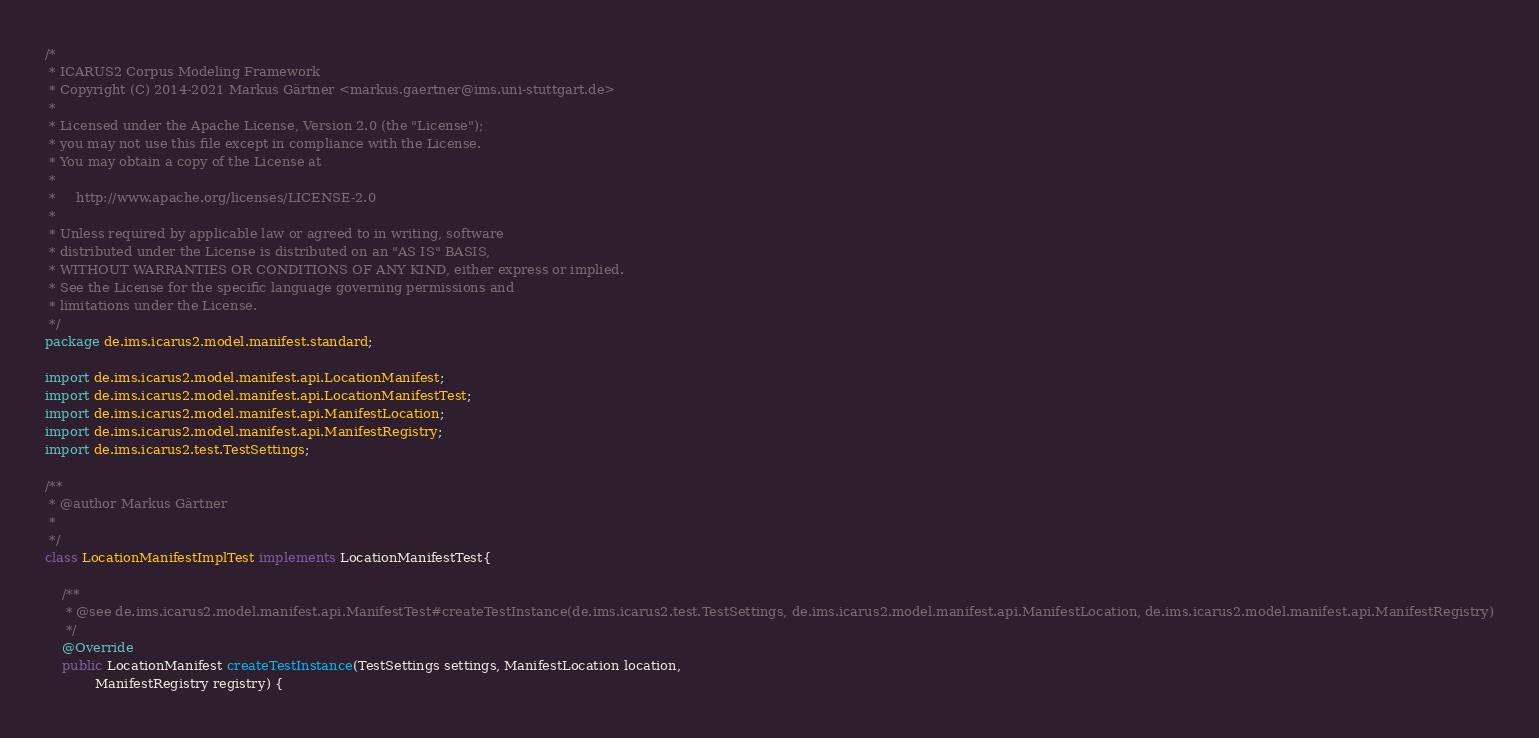<code> <loc_0><loc_0><loc_500><loc_500><_Java_>/*
 * ICARUS2 Corpus Modeling Framework
 * Copyright (C) 2014-2021 Markus Gärtner <markus.gaertner@ims.uni-stuttgart.de>
 *
 * Licensed under the Apache License, Version 2.0 (the "License");
 * you may not use this file except in compliance with the License.
 * You may obtain a copy of the License at
 *
 *     http://www.apache.org/licenses/LICENSE-2.0
 *
 * Unless required by applicable law or agreed to in writing, software
 * distributed under the License is distributed on an "AS IS" BASIS,
 * WITHOUT WARRANTIES OR CONDITIONS OF ANY KIND, either express or implied.
 * See the License for the specific language governing permissions and
 * limitations under the License.
 */
package de.ims.icarus2.model.manifest.standard;

import de.ims.icarus2.model.manifest.api.LocationManifest;
import de.ims.icarus2.model.manifest.api.LocationManifestTest;
import de.ims.icarus2.model.manifest.api.ManifestLocation;
import de.ims.icarus2.model.manifest.api.ManifestRegistry;
import de.ims.icarus2.test.TestSettings;

/**
 * @author Markus Gärtner
 *
 */
class LocationManifestImplTest implements LocationManifestTest{

	/**
	 * @see de.ims.icarus2.model.manifest.api.ManifestTest#createTestInstance(de.ims.icarus2.test.TestSettings, de.ims.icarus2.model.manifest.api.ManifestLocation, de.ims.icarus2.model.manifest.api.ManifestRegistry)
	 */
	@Override
	public LocationManifest createTestInstance(TestSettings settings, ManifestLocation location,
			ManifestRegistry registry) {</code> 